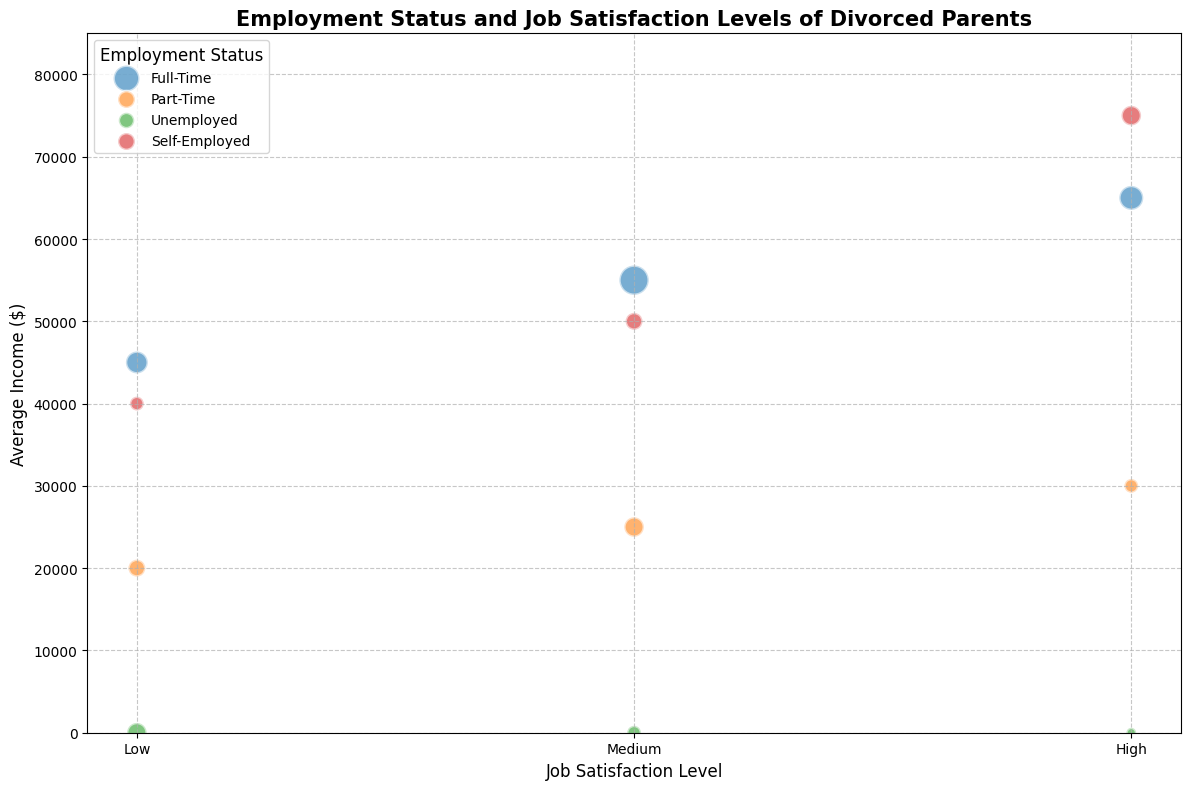Which employment status has the highest average income among those with high job satisfaction levels? The visual information shows that among those with high job satisfaction levels, the largest bubble, which represents the highest average income, corresponds to the 'Self-Employed' category.
Answer: Self-Employed Among unemployed respondents, how does the number of respondents vary across different job satisfaction levels? Looking at the different bubble sizes for 'Unemployed' employment status, the bubbles for low, medium, and high job satisfaction levels have different visual diameters. Specifically, the bubble sizes decrease from low (largest) to high (smallest).
Answer: The number decreases from low to high What is the total number of full-time respondents? To find the total number of full-time respondents, add the values from the bubbles corresponding to full-time for all job satisfaction levels: 25 (low) + 45 (medium) + 30 (high).
Answer: 100 Compare the average income between full-time and part-time respondents with medium job satisfaction levels. Which one is higher? By looking at the y-axis, we see that the average incomes for medium job satisfaction levels are represented by bubbles. The bubble for full-time is placed higher on the y-axis ($55,000) compared to the part-time bubble ($25,000).
Answer: Full-Time How does the average income of self-employed respondents with high job satisfaction compare to those with low job satisfaction within the same employment status? The self-employed category's bubbles for high and low job satisfaction levels indicate their average incomes by height. The bubble for high satisfaction is positioned at $75,000, and the one for low satisfaction is at $40,000.
Answer: Higher for high job satisfaction Does unemployed respondents with any job satisfaction level have income? Observing the y-axis placement of the bubbles for the 'Unemployed' group, all bubbles align at zero average income, indicating no income regardless of job satisfaction level.
Answer: No, they have no income Which employment status and job satisfaction combination has the smallest number of respondents? By comparing the sizes of all bubbles, the smallest bubble is for 'Unemployed' with high job satisfaction.
Answer: Unemployed with high job satisfaction What is the range of average incomes for part-time respondents? Identify the highest and lowest bubbles for 'Part-Time'. The highest is at $30,000 (high satisfaction), and the lowest is at $20,000 (low satisfaction). The range is $30,000 - $20,000.
Answer: $10,000 